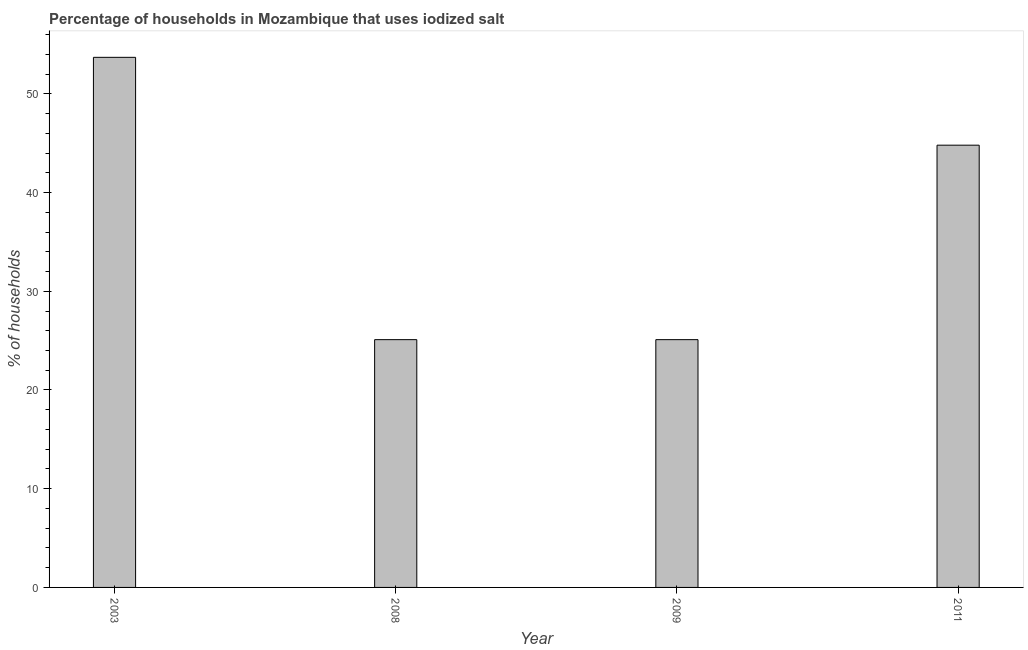Does the graph contain any zero values?
Offer a terse response. No. What is the title of the graph?
Offer a very short reply. Percentage of households in Mozambique that uses iodized salt. What is the label or title of the X-axis?
Your response must be concise. Year. What is the label or title of the Y-axis?
Make the answer very short. % of households. What is the percentage of households where iodized salt is consumed in 2008?
Keep it short and to the point. 25.1. Across all years, what is the maximum percentage of households where iodized salt is consumed?
Keep it short and to the point. 53.7. Across all years, what is the minimum percentage of households where iodized salt is consumed?
Your answer should be very brief. 25.1. In which year was the percentage of households where iodized salt is consumed minimum?
Give a very brief answer. 2008. What is the sum of the percentage of households where iodized salt is consumed?
Ensure brevity in your answer.  148.7. What is the difference between the percentage of households where iodized salt is consumed in 2003 and 2008?
Ensure brevity in your answer.  28.6. What is the average percentage of households where iodized salt is consumed per year?
Offer a very short reply. 37.17. What is the median percentage of households where iodized salt is consumed?
Offer a very short reply. 34.95. Do a majority of the years between 2009 and 2011 (inclusive) have percentage of households where iodized salt is consumed greater than 8 %?
Ensure brevity in your answer.  Yes. What is the ratio of the percentage of households where iodized salt is consumed in 2003 to that in 2011?
Your response must be concise. 1.2. Is the percentage of households where iodized salt is consumed in 2003 less than that in 2011?
Give a very brief answer. No. Is the difference between the percentage of households where iodized salt is consumed in 2003 and 2008 greater than the difference between any two years?
Your response must be concise. Yes. What is the difference between the highest and the second highest percentage of households where iodized salt is consumed?
Make the answer very short. 8.9. What is the difference between the highest and the lowest percentage of households where iodized salt is consumed?
Keep it short and to the point. 28.6. In how many years, is the percentage of households where iodized salt is consumed greater than the average percentage of households where iodized salt is consumed taken over all years?
Your answer should be compact. 2. How many bars are there?
Keep it short and to the point. 4. Are all the bars in the graph horizontal?
Make the answer very short. No. How many years are there in the graph?
Ensure brevity in your answer.  4. What is the % of households of 2003?
Make the answer very short. 53.7. What is the % of households in 2008?
Your answer should be very brief. 25.1. What is the % of households in 2009?
Keep it short and to the point. 25.1. What is the % of households of 2011?
Your response must be concise. 44.8. What is the difference between the % of households in 2003 and 2008?
Keep it short and to the point. 28.6. What is the difference between the % of households in 2003 and 2009?
Make the answer very short. 28.6. What is the difference between the % of households in 2003 and 2011?
Your answer should be very brief. 8.9. What is the difference between the % of households in 2008 and 2009?
Provide a succinct answer. 0. What is the difference between the % of households in 2008 and 2011?
Offer a very short reply. -19.7. What is the difference between the % of households in 2009 and 2011?
Keep it short and to the point. -19.7. What is the ratio of the % of households in 2003 to that in 2008?
Provide a succinct answer. 2.14. What is the ratio of the % of households in 2003 to that in 2009?
Offer a terse response. 2.14. What is the ratio of the % of households in 2003 to that in 2011?
Provide a succinct answer. 1.2. What is the ratio of the % of households in 2008 to that in 2009?
Keep it short and to the point. 1. What is the ratio of the % of households in 2008 to that in 2011?
Ensure brevity in your answer.  0.56. What is the ratio of the % of households in 2009 to that in 2011?
Your answer should be compact. 0.56. 